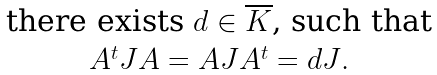Convert formula to latex. <formula><loc_0><loc_0><loc_500><loc_500>\begin{matrix} \text {there exists $d\in \overline{K}$, such that} \\ \text {$A^{t} JA=AJA^{t}=dJ$} . \end{matrix}</formula> 